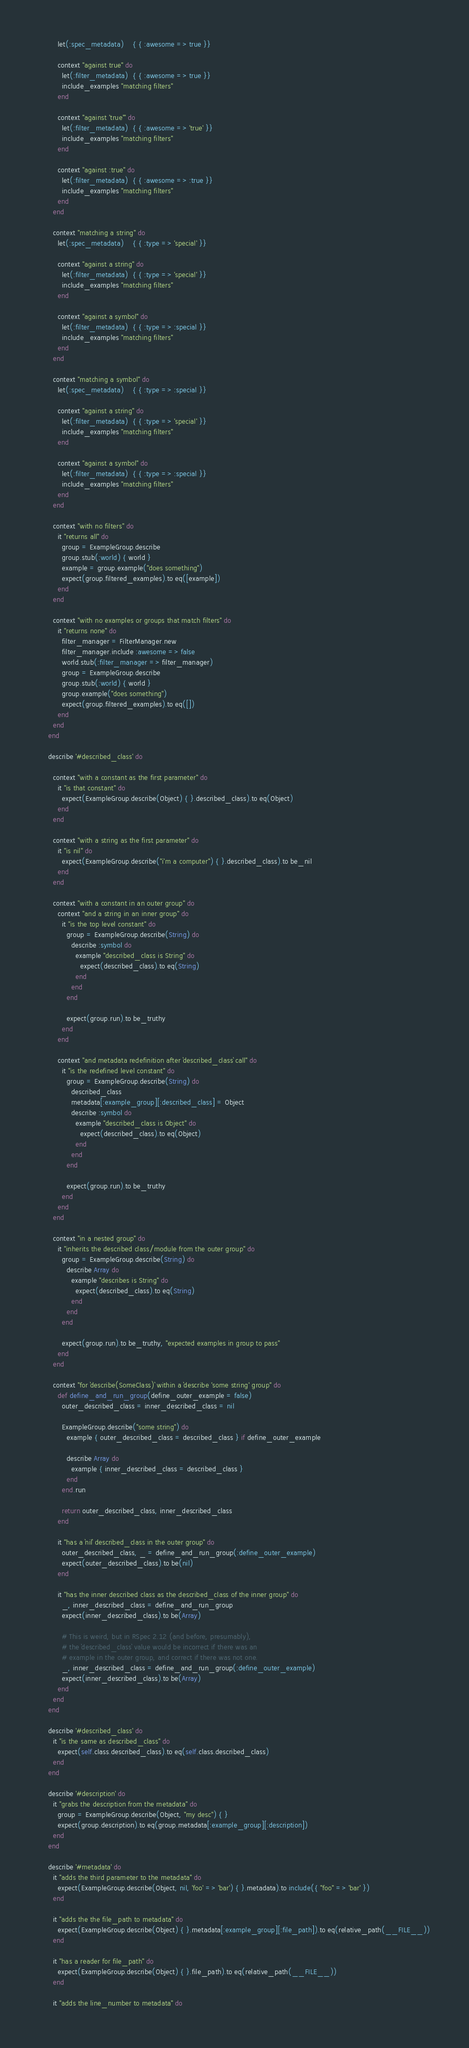Convert code to text. <code><loc_0><loc_0><loc_500><loc_500><_Ruby_>        let(:spec_metadata)    { { :awesome => true }}

        context "against true" do
          let(:filter_metadata)  { { :awesome => true }}
          include_examples "matching filters"
        end

        context "against 'true'" do
          let(:filter_metadata)  { { :awesome => 'true' }}
          include_examples "matching filters"
        end

        context "against :true" do
          let(:filter_metadata)  { { :awesome => :true }}
          include_examples "matching filters"
        end
      end

      context "matching a string" do
        let(:spec_metadata)    { { :type => 'special' }}

        context "against a string" do
          let(:filter_metadata)  { { :type => 'special' }}
          include_examples "matching filters"
        end

        context "against a symbol" do
          let(:filter_metadata)  { { :type => :special }}
          include_examples "matching filters"
        end
      end

      context "matching a symbol" do
        let(:spec_metadata)    { { :type => :special }}

        context "against a string" do
          let(:filter_metadata)  { { :type => 'special' }}
          include_examples "matching filters"
        end

        context "against a symbol" do
          let(:filter_metadata)  { { :type => :special }}
          include_examples "matching filters"
        end
      end

      context "with no filters" do
        it "returns all" do
          group = ExampleGroup.describe
          group.stub(:world) { world }
          example = group.example("does something")
          expect(group.filtered_examples).to eq([example])
        end
      end

      context "with no examples or groups that match filters" do
        it "returns none" do
          filter_manager = FilterManager.new
          filter_manager.include :awesome => false
          world.stub(:filter_manager => filter_manager)
          group = ExampleGroup.describe
          group.stub(:world) { world }
          group.example("does something")
          expect(group.filtered_examples).to eq([])
        end
      end
    end

    describe '#described_class' do

      context "with a constant as the first parameter" do
        it "is that constant" do
          expect(ExampleGroup.describe(Object) { }.described_class).to eq(Object)
        end
      end

      context "with a string as the first parameter" do
        it "is nil" do
          expect(ExampleGroup.describe("i'm a computer") { }.described_class).to be_nil
        end
      end

      context "with a constant in an outer group" do
        context "and a string in an inner group" do
          it "is the top level constant" do
            group = ExampleGroup.describe(String) do
              describe :symbol do
                example "described_class is String" do
                  expect(described_class).to eq(String)
                end
              end
            end

            expect(group.run).to be_truthy
          end
        end

        context "and metadata redefinition after `described_class` call" do
          it "is the redefined level constant" do
            group = ExampleGroup.describe(String) do
              described_class
              metadata[:example_group][:described_class] = Object
              describe :symbol do
                example "described_class is Object" do
                  expect(described_class).to eq(Object)
                end
              end
            end

            expect(group.run).to be_truthy
          end
        end
      end

      context "in a nested group" do
        it "inherits the described class/module from the outer group" do
          group = ExampleGroup.describe(String) do
            describe Array do
              example "describes is String" do
                expect(described_class).to eq(String)
              end
            end
          end

          expect(group.run).to be_truthy, "expected examples in group to pass"
        end
      end

      context "for `describe(SomeClass)` within a `describe 'some string' group" do
        def define_and_run_group(define_outer_example = false)
          outer_described_class = inner_described_class = nil

          ExampleGroup.describe("some string") do
            example { outer_described_class = described_class } if define_outer_example

            describe Array do
              example { inner_described_class = described_class }
            end
          end.run

          return outer_described_class, inner_described_class
        end

        it "has a `nil` described_class in the outer group" do
          outer_described_class, _ = define_and_run_group(:define_outer_example)
          expect(outer_described_class).to be(nil)
        end

        it "has the inner described class as the described_class of the inner group" do
          _, inner_described_class = define_and_run_group
          expect(inner_described_class).to be(Array)

          # This is weird, but in RSpec 2.12 (and before, presumably),
          # the `described_class` value would be incorrect if there was an
          # example in the outer group, and correct if there was not one.
          _, inner_described_class = define_and_run_group(:define_outer_example)
          expect(inner_described_class).to be(Array)
        end
      end
    end

    describe '#described_class' do
      it "is the same as described_class" do
        expect(self.class.described_class).to eq(self.class.described_class)
      end
    end

    describe '#description' do
      it "grabs the description from the metadata" do
        group = ExampleGroup.describe(Object, "my desc") { }
        expect(group.description).to eq(group.metadata[:example_group][:description])
      end
    end

    describe '#metadata' do
      it "adds the third parameter to the metadata" do
        expect(ExampleGroup.describe(Object, nil, 'foo' => 'bar') { }.metadata).to include({ "foo" => 'bar' })
      end

      it "adds the the file_path to metadata" do
        expect(ExampleGroup.describe(Object) { }.metadata[:example_group][:file_path]).to eq(relative_path(__FILE__))
      end

      it "has a reader for file_path" do
        expect(ExampleGroup.describe(Object) { }.file_path).to eq(relative_path(__FILE__))
      end

      it "adds the line_number to metadata" do</code> 